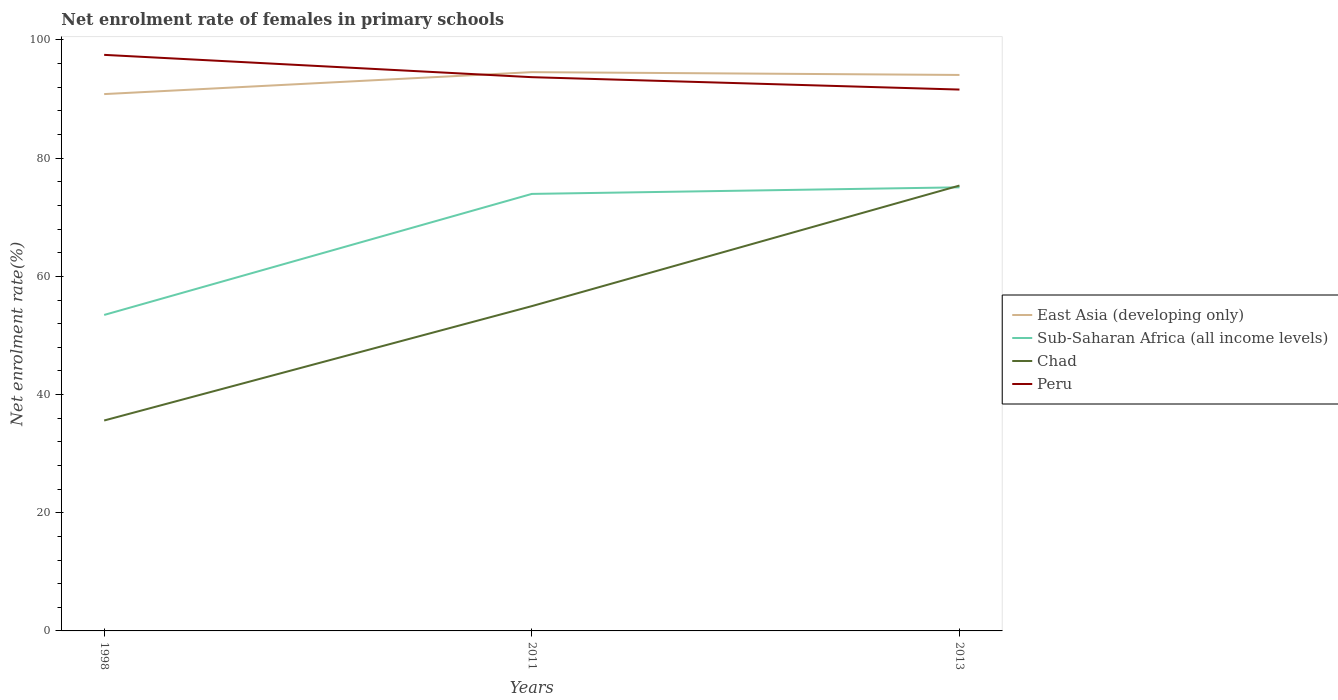How many different coloured lines are there?
Provide a succinct answer. 4. Does the line corresponding to Peru intersect with the line corresponding to East Asia (developing only)?
Make the answer very short. Yes. Is the number of lines equal to the number of legend labels?
Provide a short and direct response. Yes. Across all years, what is the maximum net enrolment rate of females in primary schools in Chad?
Ensure brevity in your answer.  35.61. What is the total net enrolment rate of females in primary schools in East Asia (developing only) in the graph?
Keep it short and to the point. -3.24. What is the difference between the highest and the second highest net enrolment rate of females in primary schools in Sub-Saharan Africa (all income levels)?
Your response must be concise. 21.6. How many lines are there?
Your answer should be very brief. 4. How many years are there in the graph?
Your response must be concise. 3. What is the difference between two consecutive major ticks on the Y-axis?
Your answer should be compact. 20. Does the graph contain any zero values?
Make the answer very short. No. Does the graph contain grids?
Your response must be concise. No. Where does the legend appear in the graph?
Offer a very short reply. Center right. How many legend labels are there?
Make the answer very short. 4. What is the title of the graph?
Keep it short and to the point. Net enrolment rate of females in primary schools. What is the label or title of the Y-axis?
Offer a very short reply. Net enrolment rate(%). What is the Net enrolment rate(%) in East Asia (developing only) in 1998?
Your answer should be very brief. 90.84. What is the Net enrolment rate(%) of Sub-Saharan Africa (all income levels) in 1998?
Provide a succinct answer. 53.47. What is the Net enrolment rate(%) of Chad in 1998?
Provide a succinct answer. 35.61. What is the Net enrolment rate(%) in Peru in 1998?
Keep it short and to the point. 97.48. What is the Net enrolment rate(%) of East Asia (developing only) in 2011?
Your answer should be compact. 94.56. What is the Net enrolment rate(%) of Sub-Saharan Africa (all income levels) in 2011?
Provide a succinct answer. 73.95. What is the Net enrolment rate(%) of Chad in 2011?
Offer a very short reply. 54.96. What is the Net enrolment rate(%) in Peru in 2011?
Provide a succinct answer. 93.71. What is the Net enrolment rate(%) of East Asia (developing only) in 2013?
Provide a short and direct response. 94.08. What is the Net enrolment rate(%) of Sub-Saharan Africa (all income levels) in 2013?
Your answer should be very brief. 75.07. What is the Net enrolment rate(%) in Chad in 2013?
Ensure brevity in your answer.  75.37. What is the Net enrolment rate(%) in Peru in 2013?
Offer a very short reply. 91.61. Across all years, what is the maximum Net enrolment rate(%) of East Asia (developing only)?
Your answer should be very brief. 94.56. Across all years, what is the maximum Net enrolment rate(%) of Sub-Saharan Africa (all income levels)?
Offer a terse response. 75.07. Across all years, what is the maximum Net enrolment rate(%) of Chad?
Your answer should be compact. 75.37. Across all years, what is the maximum Net enrolment rate(%) of Peru?
Your answer should be compact. 97.48. Across all years, what is the minimum Net enrolment rate(%) of East Asia (developing only)?
Provide a short and direct response. 90.84. Across all years, what is the minimum Net enrolment rate(%) in Sub-Saharan Africa (all income levels)?
Make the answer very short. 53.47. Across all years, what is the minimum Net enrolment rate(%) in Chad?
Ensure brevity in your answer.  35.61. Across all years, what is the minimum Net enrolment rate(%) in Peru?
Provide a succinct answer. 91.61. What is the total Net enrolment rate(%) of East Asia (developing only) in the graph?
Your answer should be compact. 279.49. What is the total Net enrolment rate(%) of Sub-Saharan Africa (all income levels) in the graph?
Make the answer very short. 202.49. What is the total Net enrolment rate(%) in Chad in the graph?
Provide a succinct answer. 165.94. What is the total Net enrolment rate(%) of Peru in the graph?
Offer a terse response. 282.8. What is the difference between the Net enrolment rate(%) in East Asia (developing only) in 1998 and that in 2011?
Your answer should be very brief. -3.72. What is the difference between the Net enrolment rate(%) of Sub-Saharan Africa (all income levels) in 1998 and that in 2011?
Your answer should be very brief. -20.48. What is the difference between the Net enrolment rate(%) of Chad in 1998 and that in 2011?
Offer a very short reply. -19.36. What is the difference between the Net enrolment rate(%) in Peru in 1998 and that in 2011?
Ensure brevity in your answer.  3.78. What is the difference between the Net enrolment rate(%) in East Asia (developing only) in 1998 and that in 2013?
Offer a terse response. -3.24. What is the difference between the Net enrolment rate(%) in Sub-Saharan Africa (all income levels) in 1998 and that in 2013?
Your answer should be very brief. -21.6. What is the difference between the Net enrolment rate(%) in Chad in 1998 and that in 2013?
Provide a short and direct response. -39.76. What is the difference between the Net enrolment rate(%) of Peru in 1998 and that in 2013?
Give a very brief answer. 5.87. What is the difference between the Net enrolment rate(%) of East Asia (developing only) in 2011 and that in 2013?
Offer a terse response. 0.48. What is the difference between the Net enrolment rate(%) in Sub-Saharan Africa (all income levels) in 2011 and that in 2013?
Ensure brevity in your answer.  -1.11. What is the difference between the Net enrolment rate(%) in Chad in 2011 and that in 2013?
Your answer should be compact. -20.4. What is the difference between the Net enrolment rate(%) in Peru in 2011 and that in 2013?
Your answer should be compact. 2.1. What is the difference between the Net enrolment rate(%) in East Asia (developing only) in 1998 and the Net enrolment rate(%) in Sub-Saharan Africa (all income levels) in 2011?
Your answer should be compact. 16.89. What is the difference between the Net enrolment rate(%) in East Asia (developing only) in 1998 and the Net enrolment rate(%) in Chad in 2011?
Your answer should be compact. 35.88. What is the difference between the Net enrolment rate(%) of East Asia (developing only) in 1998 and the Net enrolment rate(%) of Peru in 2011?
Provide a succinct answer. -2.87. What is the difference between the Net enrolment rate(%) of Sub-Saharan Africa (all income levels) in 1998 and the Net enrolment rate(%) of Chad in 2011?
Your answer should be very brief. -1.49. What is the difference between the Net enrolment rate(%) of Sub-Saharan Africa (all income levels) in 1998 and the Net enrolment rate(%) of Peru in 2011?
Provide a short and direct response. -40.24. What is the difference between the Net enrolment rate(%) in Chad in 1998 and the Net enrolment rate(%) in Peru in 2011?
Provide a short and direct response. -58.1. What is the difference between the Net enrolment rate(%) of East Asia (developing only) in 1998 and the Net enrolment rate(%) of Sub-Saharan Africa (all income levels) in 2013?
Your answer should be compact. 15.78. What is the difference between the Net enrolment rate(%) in East Asia (developing only) in 1998 and the Net enrolment rate(%) in Chad in 2013?
Give a very brief answer. 15.48. What is the difference between the Net enrolment rate(%) in East Asia (developing only) in 1998 and the Net enrolment rate(%) in Peru in 2013?
Your answer should be compact. -0.77. What is the difference between the Net enrolment rate(%) in Sub-Saharan Africa (all income levels) in 1998 and the Net enrolment rate(%) in Chad in 2013?
Ensure brevity in your answer.  -21.9. What is the difference between the Net enrolment rate(%) of Sub-Saharan Africa (all income levels) in 1998 and the Net enrolment rate(%) of Peru in 2013?
Offer a terse response. -38.14. What is the difference between the Net enrolment rate(%) of Chad in 1998 and the Net enrolment rate(%) of Peru in 2013?
Offer a terse response. -56. What is the difference between the Net enrolment rate(%) of East Asia (developing only) in 2011 and the Net enrolment rate(%) of Sub-Saharan Africa (all income levels) in 2013?
Your answer should be very brief. 19.49. What is the difference between the Net enrolment rate(%) of East Asia (developing only) in 2011 and the Net enrolment rate(%) of Chad in 2013?
Offer a very short reply. 19.19. What is the difference between the Net enrolment rate(%) in East Asia (developing only) in 2011 and the Net enrolment rate(%) in Peru in 2013?
Ensure brevity in your answer.  2.95. What is the difference between the Net enrolment rate(%) of Sub-Saharan Africa (all income levels) in 2011 and the Net enrolment rate(%) of Chad in 2013?
Your answer should be very brief. -1.41. What is the difference between the Net enrolment rate(%) of Sub-Saharan Africa (all income levels) in 2011 and the Net enrolment rate(%) of Peru in 2013?
Your answer should be very brief. -17.66. What is the difference between the Net enrolment rate(%) in Chad in 2011 and the Net enrolment rate(%) in Peru in 2013?
Offer a terse response. -36.65. What is the average Net enrolment rate(%) in East Asia (developing only) per year?
Give a very brief answer. 93.16. What is the average Net enrolment rate(%) in Sub-Saharan Africa (all income levels) per year?
Make the answer very short. 67.5. What is the average Net enrolment rate(%) of Chad per year?
Keep it short and to the point. 55.31. What is the average Net enrolment rate(%) in Peru per year?
Ensure brevity in your answer.  94.27. In the year 1998, what is the difference between the Net enrolment rate(%) of East Asia (developing only) and Net enrolment rate(%) of Sub-Saharan Africa (all income levels)?
Your answer should be compact. 37.37. In the year 1998, what is the difference between the Net enrolment rate(%) of East Asia (developing only) and Net enrolment rate(%) of Chad?
Offer a very short reply. 55.24. In the year 1998, what is the difference between the Net enrolment rate(%) in East Asia (developing only) and Net enrolment rate(%) in Peru?
Ensure brevity in your answer.  -6.64. In the year 1998, what is the difference between the Net enrolment rate(%) of Sub-Saharan Africa (all income levels) and Net enrolment rate(%) of Chad?
Offer a terse response. 17.86. In the year 1998, what is the difference between the Net enrolment rate(%) in Sub-Saharan Africa (all income levels) and Net enrolment rate(%) in Peru?
Provide a succinct answer. -44.01. In the year 1998, what is the difference between the Net enrolment rate(%) of Chad and Net enrolment rate(%) of Peru?
Keep it short and to the point. -61.88. In the year 2011, what is the difference between the Net enrolment rate(%) of East Asia (developing only) and Net enrolment rate(%) of Sub-Saharan Africa (all income levels)?
Offer a terse response. 20.61. In the year 2011, what is the difference between the Net enrolment rate(%) of East Asia (developing only) and Net enrolment rate(%) of Chad?
Provide a short and direct response. 39.6. In the year 2011, what is the difference between the Net enrolment rate(%) in East Asia (developing only) and Net enrolment rate(%) in Peru?
Offer a terse response. 0.85. In the year 2011, what is the difference between the Net enrolment rate(%) in Sub-Saharan Africa (all income levels) and Net enrolment rate(%) in Chad?
Offer a terse response. 18.99. In the year 2011, what is the difference between the Net enrolment rate(%) in Sub-Saharan Africa (all income levels) and Net enrolment rate(%) in Peru?
Your answer should be very brief. -19.76. In the year 2011, what is the difference between the Net enrolment rate(%) of Chad and Net enrolment rate(%) of Peru?
Keep it short and to the point. -38.75. In the year 2013, what is the difference between the Net enrolment rate(%) of East Asia (developing only) and Net enrolment rate(%) of Sub-Saharan Africa (all income levels)?
Your response must be concise. 19.02. In the year 2013, what is the difference between the Net enrolment rate(%) in East Asia (developing only) and Net enrolment rate(%) in Chad?
Give a very brief answer. 18.72. In the year 2013, what is the difference between the Net enrolment rate(%) in East Asia (developing only) and Net enrolment rate(%) in Peru?
Provide a succinct answer. 2.47. In the year 2013, what is the difference between the Net enrolment rate(%) of Sub-Saharan Africa (all income levels) and Net enrolment rate(%) of Chad?
Provide a succinct answer. -0.3. In the year 2013, what is the difference between the Net enrolment rate(%) in Sub-Saharan Africa (all income levels) and Net enrolment rate(%) in Peru?
Provide a short and direct response. -16.54. In the year 2013, what is the difference between the Net enrolment rate(%) in Chad and Net enrolment rate(%) in Peru?
Provide a short and direct response. -16.24. What is the ratio of the Net enrolment rate(%) in East Asia (developing only) in 1998 to that in 2011?
Your answer should be compact. 0.96. What is the ratio of the Net enrolment rate(%) of Sub-Saharan Africa (all income levels) in 1998 to that in 2011?
Keep it short and to the point. 0.72. What is the ratio of the Net enrolment rate(%) of Chad in 1998 to that in 2011?
Provide a succinct answer. 0.65. What is the ratio of the Net enrolment rate(%) of Peru in 1998 to that in 2011?
Provide a succinct answer. 1.04. What is the ratio of the Net enrolment rate(%) in East Asia (developing only) in 1998 to that in 2013?
Offer a very short reply. 0.97. What is the ratio of the Net enrolment rate(%) of Sub-Saharan Africa (all income levels) in 1998 to that in 2013?
Your response must be concise. 0.71. What is the ratio of the Net enrolment rate(%) of Chad in 1998 to that in 2013?
Keep it short and to the point. 0.47. What is the ratio of the Net enrolment rate(%) of Peru in 1998 to that in 2013?
Your answer should be very brief. 1.06. What is the ratio of the Net enrolment rate(%) in Sub-Saharan Africa (all income levels) in 2011 to that in 2013?
Ensure brevity in your answer.  0.99. What is the ratio of the Net enrolment rate(%) of Chad in 2011 to that in 2013?
Give a very brief answer. 0.73. What is the ratio of the Net enrolment rate(%) of Peru in 2011 to that in 2013?
Provide a short and direct response. 1.02. What is the difference between the highest and the second highest Net enrolment rate(%) of East Asia (developing only)?
Keep it short and to the point. 0.48. What is the difference between the highest and the second highest Net enrolment rate(%) of Sub-Saharan Africa (all income levels)?
Provide a short and direct response. 1.11. What is the difference between the highest and the second highest Net enrolment rate(%) in Chad?
Offer a terse response. 20.4. What is the difference between the highest and the second highest Net enrolment rate(%) in Peru?
Offer a terse response. 3.78. What is the difference between the highest and the lowest Net enrolment rate(%) of East Asia (developing only)?
Offer a terse response. 3.72. What is the difference between the highest and the lowest Net enrolment rate(%) in Sub-Saharan Africa (all income levels)?
Provide a succinct answer. 21.6. What is the difference between the highest and the lowest Net enrolment rate(%) in Chad?
Your answer should be compact. 39.76. What is the difference between the highest and the lowest Net enrolment rate(%) of Peru?
Keep it short and to the point. 5.87. 